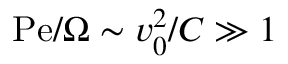<formula> <loc_0><loc_0><loc_500><loc_500>P e / \Omega \sim v _ { 0 } ^ { 2 } / C \gg 1</formula> 